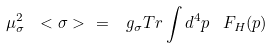Convert formula to latex. <formula><loc_0><loc_0><loc_500><loc_500>\mu _ { \sigma } ^ { 2 } \ < \sigma > \ = \ \, g _ { \sigma } T r \int d ^ { 4 } p \, \ F _ { H } ( p )</formula> 